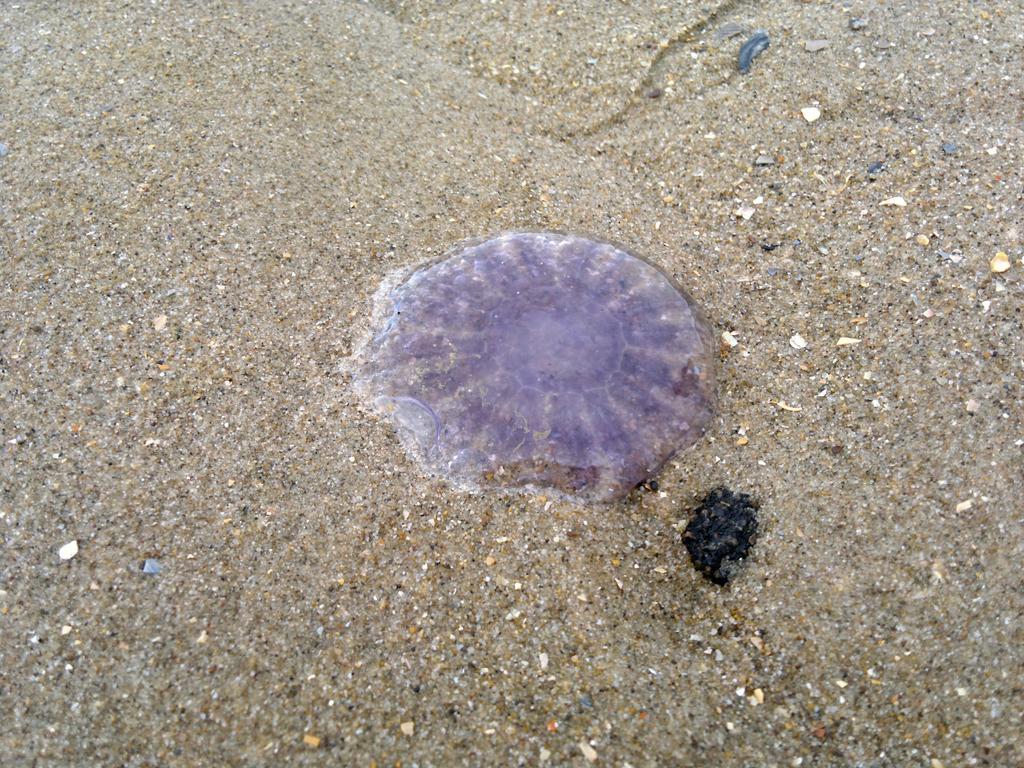In one or two sentences, can you explain what this image depicts? In this picture, it seems to be a sea shell in the center of the image on a sand floor. 